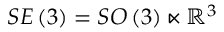<formula> <loc_0><loc_0><loc_500><loc_500>S E \left ( 3 \right ) = S O \left ( 3 \right ) \ltimes { \mathbb { R } } ^ { 3 }</formula> 